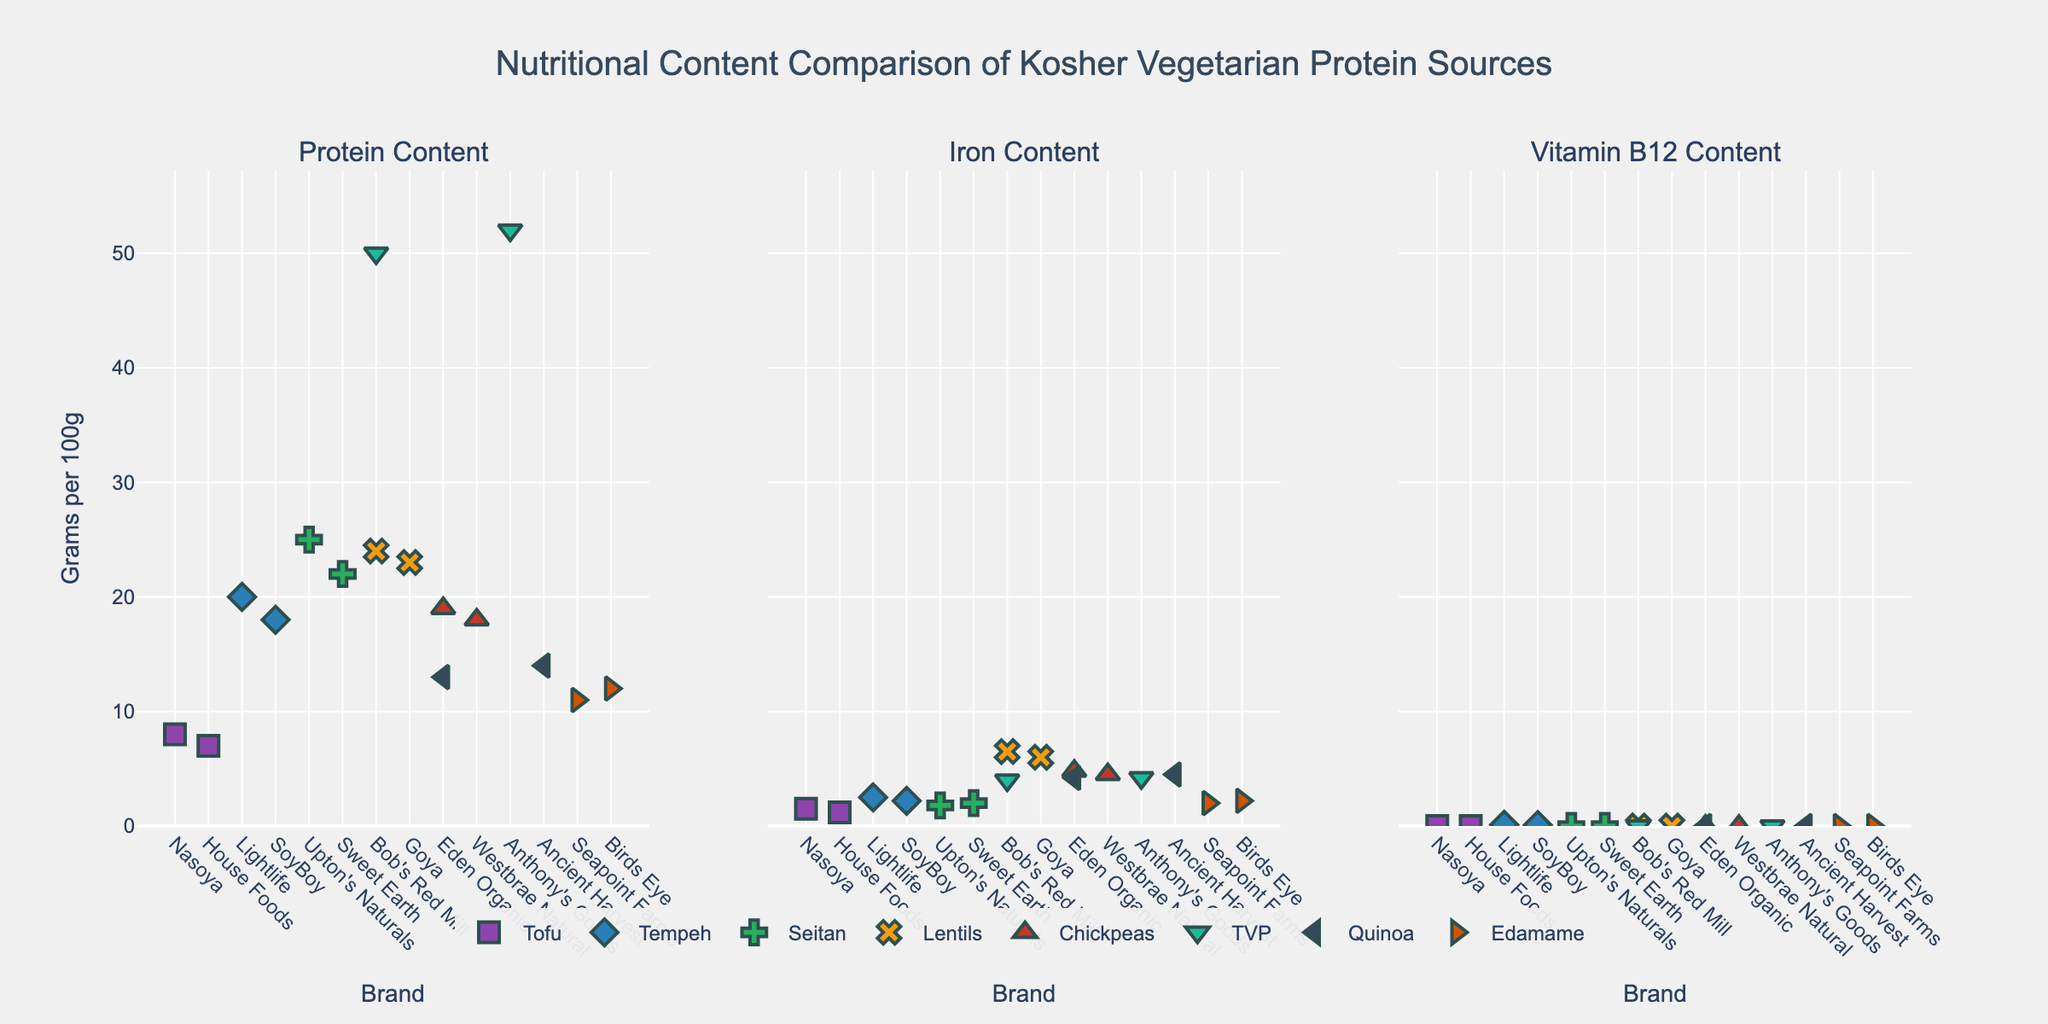Which protein source has the highest protein content across all brands? By looking at the subplot titled "Protein Content," check which point has the highest position on the y-axis. The highest protein content belongs to TVP from Anthony's Goods.
Answer: TVP (Anthony's Goods) Which brand of lentils contains more iron: Bob's Red Mill or Goya? By examining the "Iron Content" subplot and comparing the points for Lentils from Bob's Red Mill and Goya, you can see that Bob's Red Mill has a higher y-axis value.
Answer: Bob's Red Mill Are there any protein sources that contain Vitamin B12? By looking at the subplot titled "Vitamin B12 Content," you can see that only Tempeh from Lightlife and SoyBoy contain Vitamin B12, indicated by non-zero points.
Answer: Tempeh Which brand of Edamame contains more protein? In the "Protein Content" subplot, compare the y-axis positions of the points for Edamame from Seapoint Farms and Birds Eye. Birds Eye's value is higher.
Answer: Birds Eye What is the range of iron content for Chickpeas across different brands? In the "Iron Content" subplot, locate the iron values for Chickpeas from Eden Organic and Westbrae Natural. The iron content ranges from 4.5 to 4.8 grams per 100g.
Answer: 4.5 - 4.8 g Which protein source shows the most significant variation in protein content across brands? By examining the "Protein Content" subplot, compare the spread of points for each protein source. Tofu has the largest variation, ranging from 7 to 8 grams per 100g.
Answer: Tofu How does the iron content of Seitan compare to Quinoa across brands? Look at the "Iron Content" subplot. Seitan's iron content ranges from 1.8 to 2.0, while Quinoa ranges from 4.2 to 4.5 grams per 100g. Quinoa has higher iron content.
Answer: Quinoa What is the median protein content for all listed protein sources? List all protein values: 7, 8, 11, 12, 13, 14, 18, 18, 19, 20, 22, 23, 24, 25, 50, 52. The middle values are 18 and 19, so the median is (18 + 19) / 2 = 18.5 grams per 100g.
Answer: 18.5 g Which brand contains the most iron among all protein sources? In the "Iron Content" subplot, identify the highest y-axis value. Bob's Red Mill Lentils have the highest iron content.
Answer: Bob's Red Mill 